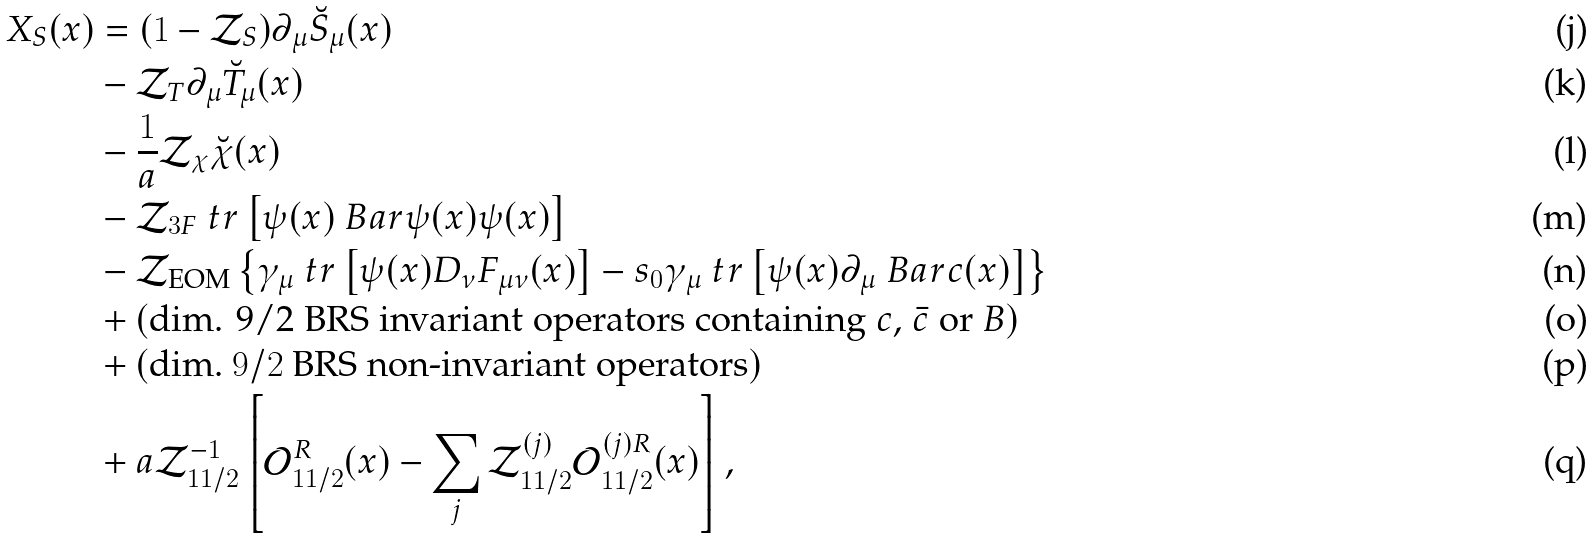Convert formula to latex. <formula><loc_0><loc_0><loc_500><loc_500>X _ { S } ( x ) & = ( 1 - \mathcal { Z } _ { S } ) \partial _ { \mu } \breve { S } _ { \mu } ( x ) \\ & - \mathcal { Z } _ { T } \partial _ { \mu } \breve { T } _ { \mu } ( x ) \\ & - \frac { 1 } { a } \mathcal { Z } _ { \chi } \breve { \chi } ( x ) \\ & - \mathcal { Z } _ { 3 F } \ t r \left [ \psi ( x ) \ B a r { \psi } ( x ) \psi ( x ) \right ] \\ & - \mathcal { Z } _ { \text {EOM} } \left \{ \gamma _ { \mu } \ t r \left [ \psi ( x ) D _ { \nu } F _ { \mu \nu } ( x ) \right ] - s _ { 0 } \gamma _ { \mu } \ t r \left [ \psi ( x ) \partial _ { \mu } \ B a r { c } ( x ) \right ] \right \} \\ & + ( \text {dim. 9/2 BRS invariant operators containing $c$, $\Bar{c}$ or $B$} ) \\ & + ( \text {dim.\ $9/2$ BRS non-invariant operators} ) \\ & + a \mathcal { Z } _ { 1 1 / 2 } ^ { - 1 } \left [ \mathcal { O } _ { 1 1 / 2 } ^ { R } ( x ) - \sum _ { j } \mathcal { Z } _ { 1 1 / 2 } ^ { ( j ) } \mathcal { O } _ { 1 1 / 2 } ^ { ( j ) R } ( x ) \right ] ,</formula> 